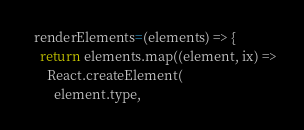<code> <loc_0><loc_0><loc_500><loc_500><_JavaScript_>
  renderElements=(elements) => {
    return elements.map((element, ix) =>
      React.createElement(
        element.type,</code> 